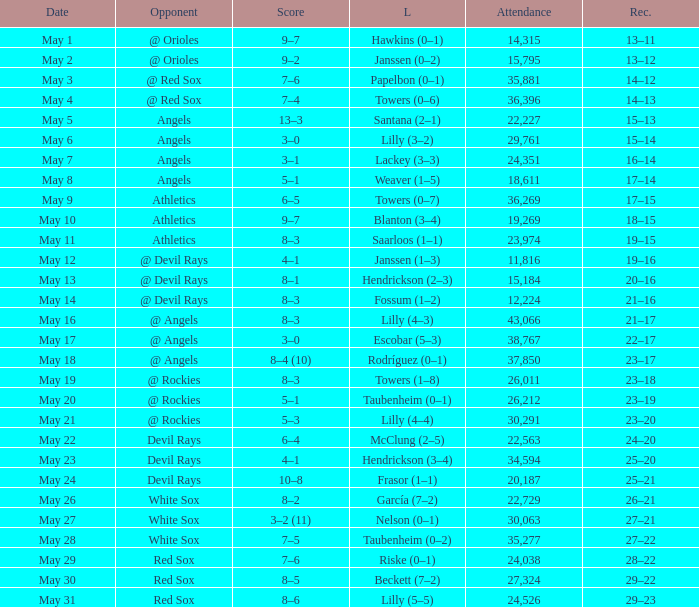Could you parse the entire table? {'header': ['Date', 'Opponent', 'Score', 'L', 'Attendance', 'Rec.'], 'rows': [['May 1', '@ Orioles', '9–7', 'Hawkins (0–1)', '14,315', '13–11'], ['May 2', '@ Orioles', '9–2', 'Janssen (0–2)', '15,795', '13–12'], ['May 3', '@ Red Sox', '7–6', 'Papelbon (0–1)', '35,881', '14–12'], ['May 4', '@ Red Sox', '7–4', 'Towers (0–6)', '36,396', '14–13'], ['May 5', 'Angels', '13–3', 'Santana (2–1)', '22,227', '15–13'], ['May 6', 'Angels', '3–0', 'Lilly (3–2)', '29,761', '15–14'], ['May 7', 'Angels', '3–1', 'Lackey (3–3)', '24,351', '16–14'], ['May 8', 'Angels', '5–1', 'Weaver (1–5)', '18,611', '17–14'], ['May 9', 'Athletics', '6–5', 'Towers (0–7)', '36,269', '17–15'], ['May 10', 'Athletics', '9–7', 'Blanton (3–4)', '19,269', '18–15'], ['May 11', 'Athletics', '8–3', 'Saarloos (1–1)', '23,974', '19–15'], ['May 12', '@ Devil Rays', '4–1', 'Janssen (1–3)', '11,816', '19–16'], ['May 13', '@ Devil Rays', '8–1', 'Hendrickson (2–3)', '15,184', '20–16'], ['May 14', '@ Devil Rays', '8–3', 'Fossum (1–2)', '12,224', '21–16'], ['May 16', '@ Angels', '8–3', 'Lilly (4–3)', '43,066', '21–17'], ['May 17', '@ Angels', '3–0', 'Escobar (5–3)', '38,767', '22–17'], ['May 18', '@ Angels', '8–4 (10)', 'Rodríguez (0–1)', '37,850', '23–17'], ['May 19', '@ Rockies', '8–3', 'Towers (1–8)', '26,011', '23–18'], ['May 20', '@ Rockies', '5–1', 'Taubenheim (0–1)', '26,212', '23–19'], ['May 21', '@ Rockies', '5–3', 'Lilly (4–4)', '30,291', '23–20'], ['May 22', 'Devil Rays', '6–4', 'McClung (2–5)', '22,563', '24–20'], ['May 23', 'Devil Rays', '4–1', 'Hendrickson (3–4)', '34,594', '25–20'], ['May 24', 'Devil Rays', '10–8', 'Frasor (1–1)', '20,187', '25–21'], ['May 26', 'White Sox', '8–2', 'García (7–2)', '22,729', '26–21'], ['May 27', 'White Sox', '3–2 (11)', 'Nelson (0–1)', '30,063', '27–21'], ['May 28', 'White Sox', '7–5', 'Taubenheim (0–2)', '35,277', '27–22'], ['May 29', 'Red Sox', '7–6', 'Riske (0–1)', '24,038', '28–22'], ['May 30', 'Red Sox', '8–5', 'Beckett (7–2)', '27,324', '29–22'], ['May 31', 'Red Sox', '8–6', 'Lilly (5–5)', '24,526', '29–23']]} When the team had their record of 16–14, what was the total attendance? 1.0. 